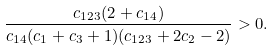<formula> <loc_0><loc_0><loc_500><loc_500>\frac { c _ { 1 2 3 } ( 2 + c _ { 1 4 } ) } { c _ { 1 4 } ( c _ { 1 } + c _ { 3 } + 1 ) ( c _ { 1 2 3 } + 2 c _ { 2 } - 2 ) } > 0 .</formula> 